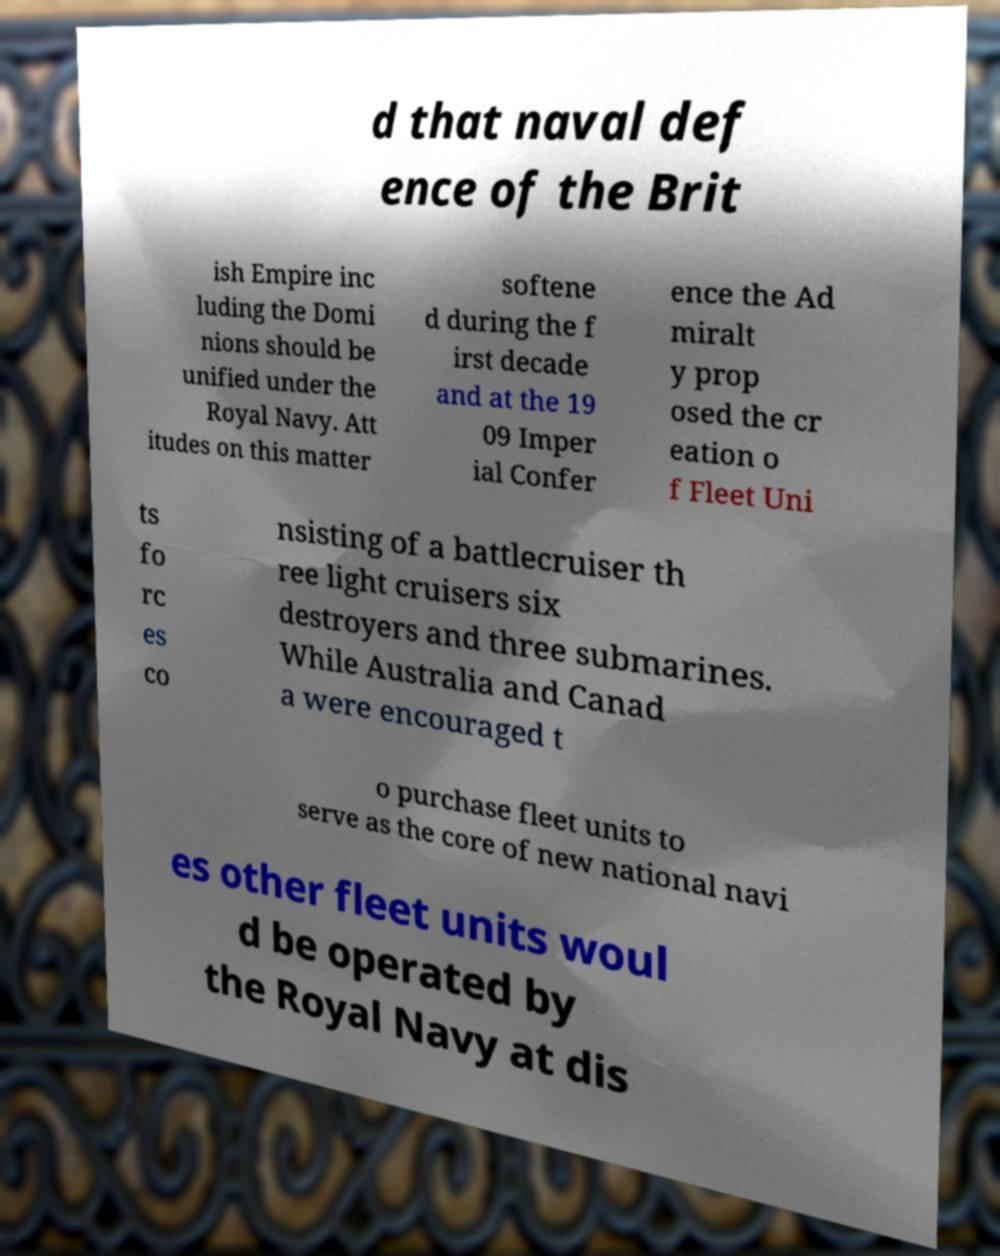What messages or text are displayed in this image? I need them in a readable, typed format. d that naval def ence of the Brit ish Empire inc luding the Domi nions should be unified under the Royal Navy. Att itudes on this matter softene d during the f irst decade and at the 19 09 Imper ial Confer ence the Ad miralt y prop osed the cr eation o f Fleet Uni ts fo rc es co nsisting of a battlecruiser th ree light cruisers six destroyers and three submarines. While Australia and Canad a were encouraged t o purchase fleet units to serve as the core of new national navi es other fleet units woul d be operated by the Royal Navy at dis 